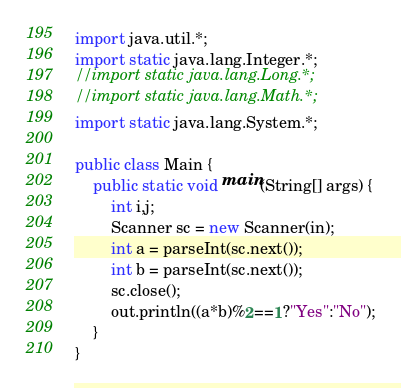Convert code to text. <code><loc_0><loc_0><loc_500><loc_500><_Java_>import java.util.*;
import static java.lang.Integer.*;
//import static java.lang.Long.*;
//import static java.lang.Math.*;
import static java.lang.System.*;

public class Main {
	public static void main(String[] args) {
		int i,j;
		Scanner sc = new Scanner(in);
		int a = parseInt(sc.next());
		int b = parseInt(sc.next());
		sc.close();
		out.println((a*b)%2==1?"Yes":"No");
	}
}
</code> 